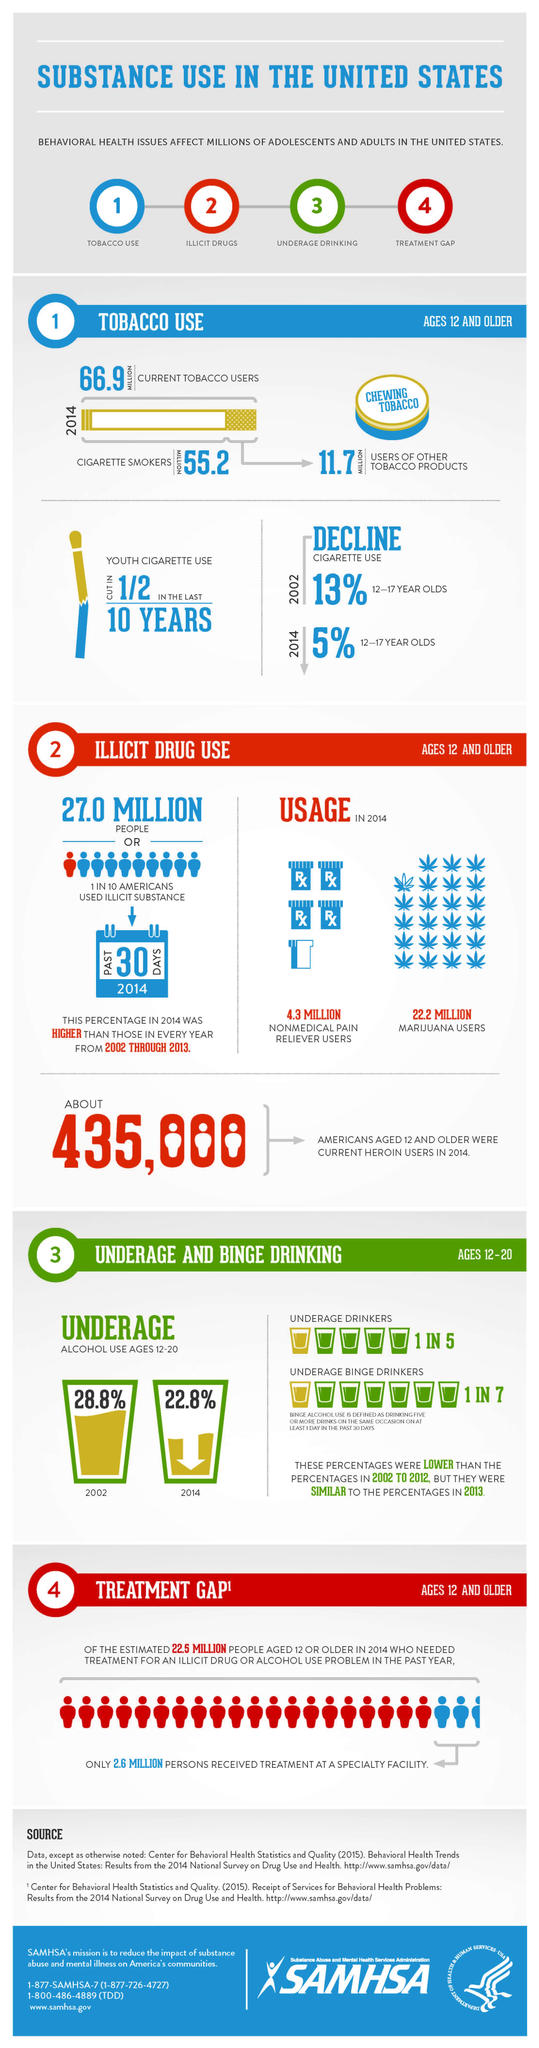Outline some significant characteristics in this image. According to estimates, approximately 26.5 million people in the United States have used illicit drugs through non-medical pain relievers and marijuana in the past year. Approximately 4% of adolescents and adults in the United States are affected by behavioral health issues. During the period between 2002 and 2014, there was a significant decline in cigarette use, with an 8% decrease. The percentage decrease in alcohol use between the year 2002 and 2014 was 6%. 